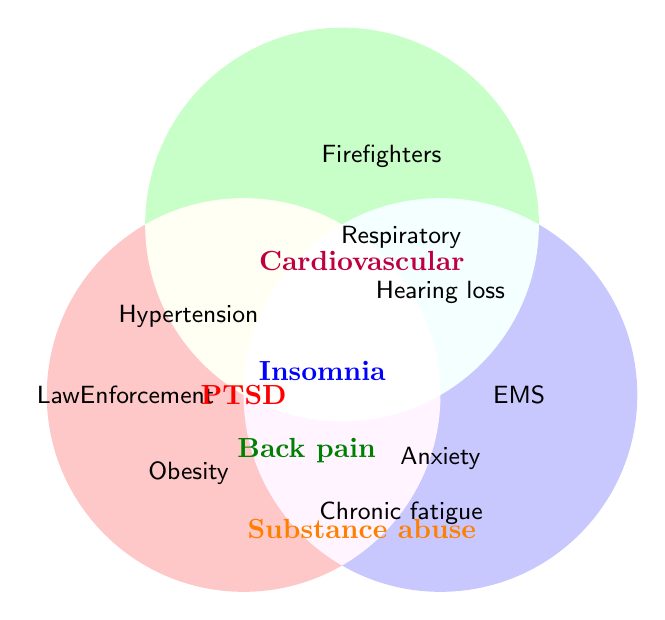What health issues are shared among all three high-stress occupations? PTSD is located at the intersection of all three circles, indicating it is common to Law Enforcement, Firefighters, and EMS.
Answer: PTSD Which health issues are unique to firefighters only? The health issues that appear within the green circle but not at any of the intersections with other circles are Respiratory issues and Hearing loss.
Answer: Respiratory issues, Hearing loss What health issues are shared between Law Enforcement and Firefighters but not with EMS? Insomnia is at the intersection between Law Enforcement and Firefighters, but not overlapping with EMS.
Answer: Insomnia What are the health issues shared between Law Enforcement and EMS only? Lower back pain appears at the intersection between Law Enforcement and EMS only.
Answer: Lower back pain Identify a health issue shared between Firefighters and EMS, but not found in Law Enforcement. There are no health issues at the intersection of Firefighters and EMS that do not intersect with Law Enforcement as well. All intersections have Law Enforcement involvement.
Answer: None 